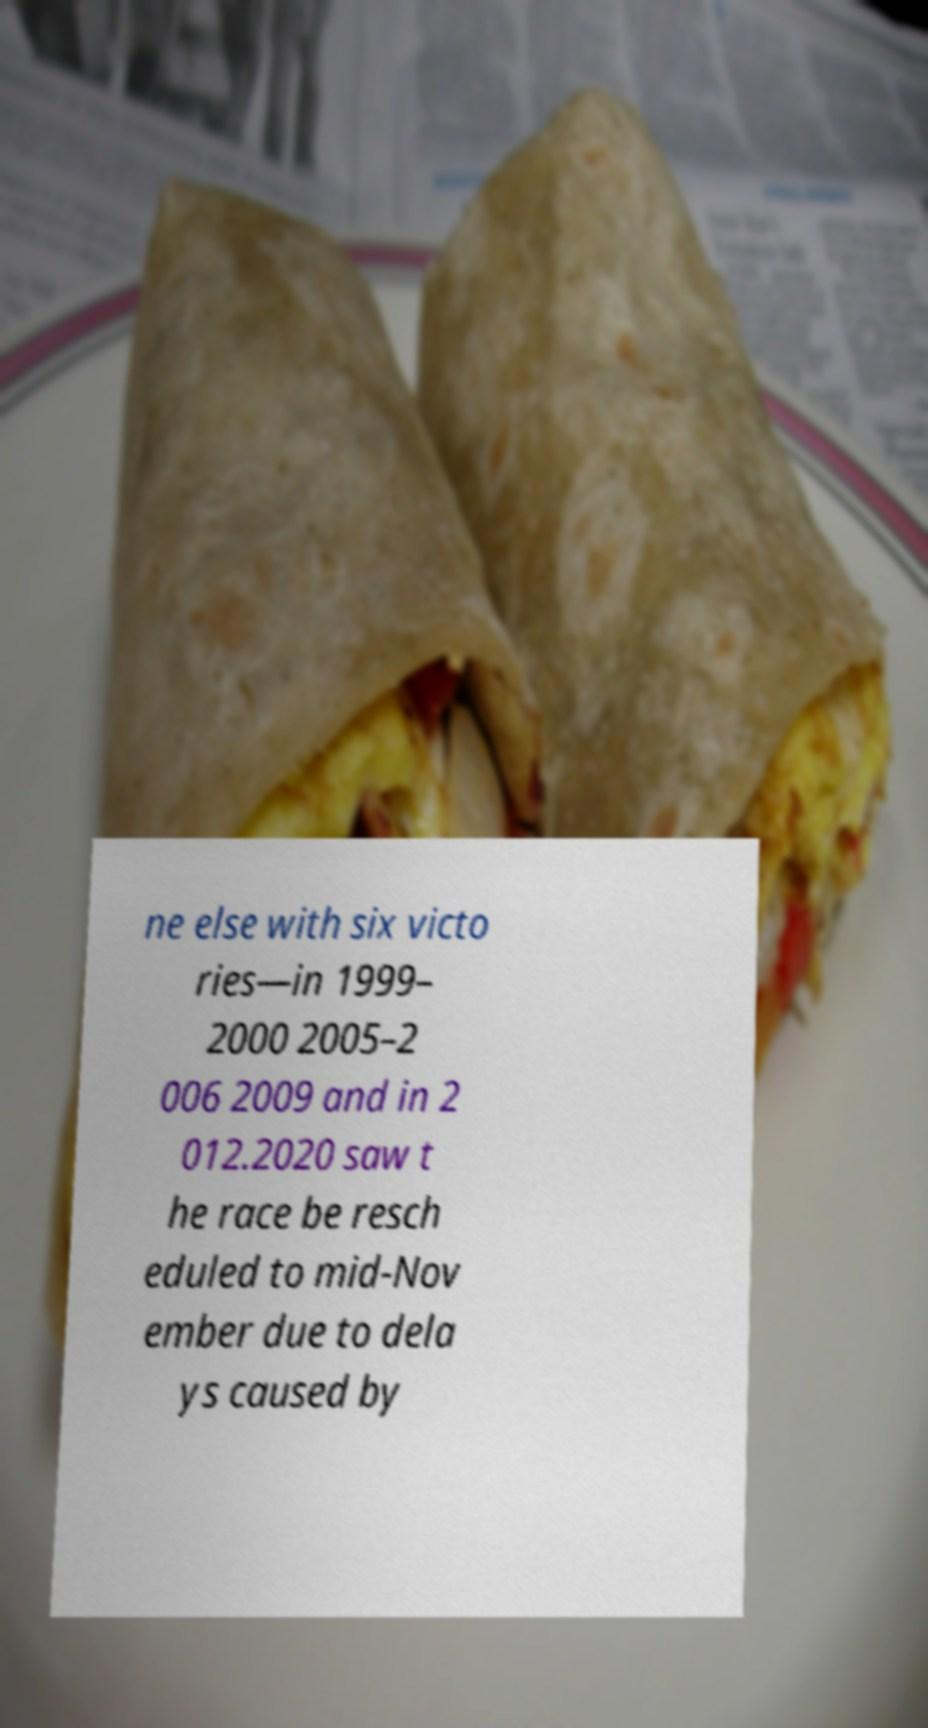Can you read and provide the text displayed in the image?This photo seems to have some interesting text. Can you extract and type it out for me? ne else with six victo ries—in 1999– 2000 2005–2 006 2009 and in 2 012.2020 saw t he race be resch eduled to mid-Nov ember due to dela ys caused by 